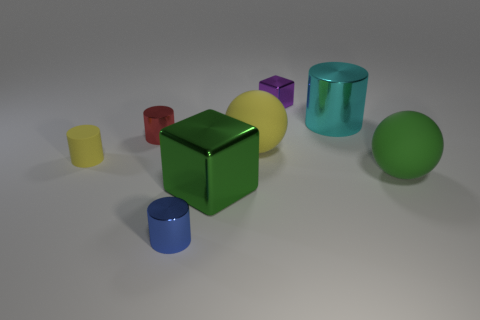Subtract all large cyan cylinders. How many cylinders are left? 3 Subtract all red cylinders. How many cylinders are left? 3 Add 2 blue matte cubes. How many objects exist? 10 Subtract all blocks. How many objects are left? 6 Subtract all gray cylinders. Subtract all green balls. How many cylinders are left? 4 Add 5 red cylinders. How many red cylinders are left? 6 Add 5 yellow shiny objects. How many yellow shiny objects exist? 5 Subtract 1 blue cylinders. How many objects are left? 7 Subtract all small yellow objects. Subtract all matte objects. How many objects are left? 4 